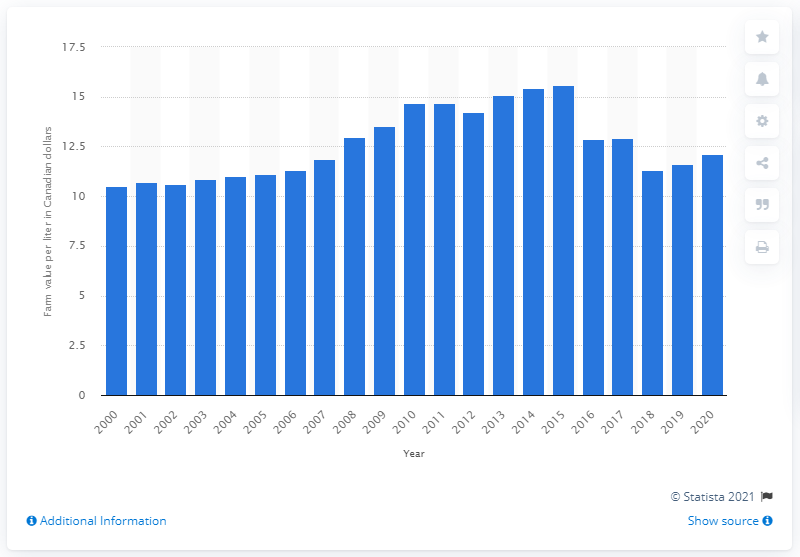Specify some key components in this picture. The value of maple syrup produced on farms in Ontario in 2020 was $12.13 per liter in dollars. The farm gate value of one liter of maple syrup in Ontario in 2015 was CAD 15.59. 